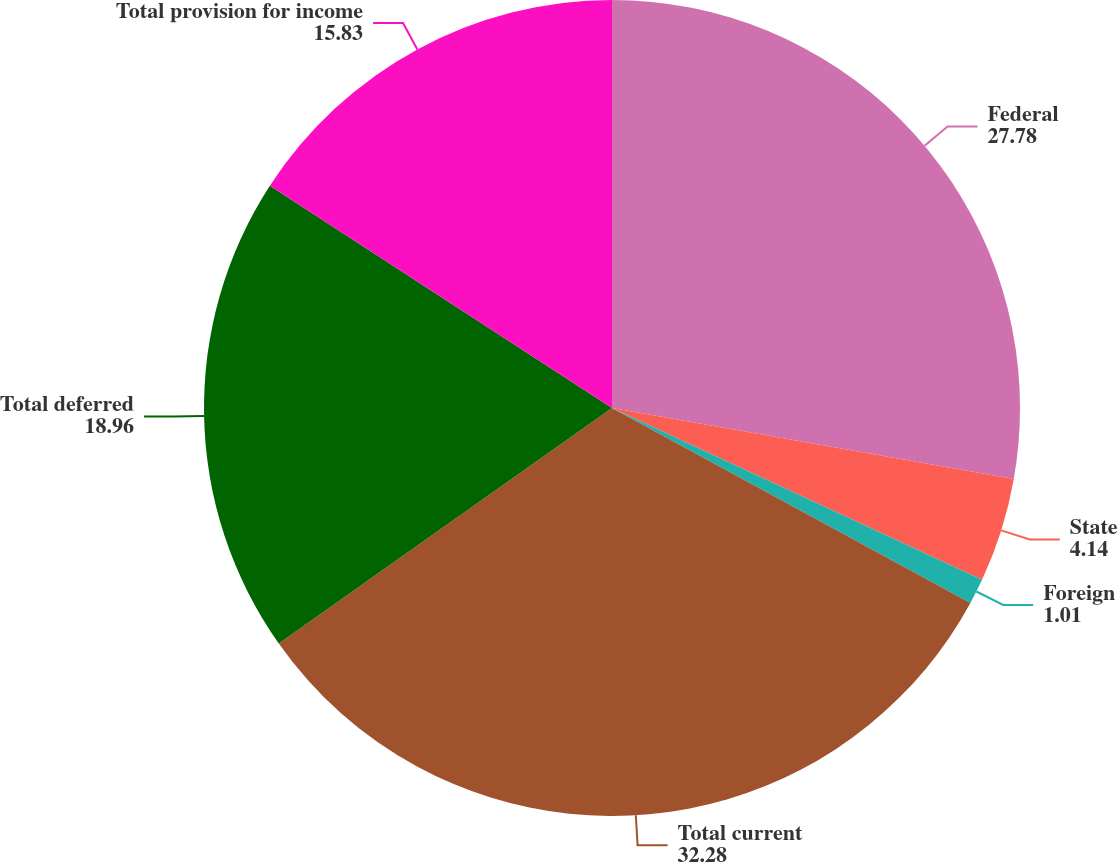Convert chart. <chart><loc_0><loc_0><loc_500><loc_500><pie_chart><fcel>Federal<fcel>State<fcel>Foreign<fcel>Total current<fcel>Total deferred<fcel>Total provision for income<nl><fcel>27.78%<fcel>4.14%<fcel>1.01%<fcel>32.28%<fcel>18.96%<fcel>15.83%<nl></chart> 